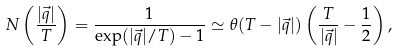Convert formula to latex. <formula><loc_0><loc_0><loc_500><loc_500>N \left ( \frac { | \vec { q } | } { T } \right ) = \frac { 1 } { \exp ( | \vec { q } | / T ) - 1 } \simeq \theta ( T - | \vec { q } | ) \left ( \frac { T } { | \vec { q } | } - \frac { 1 } { 2 } \right ) ,</formula> 